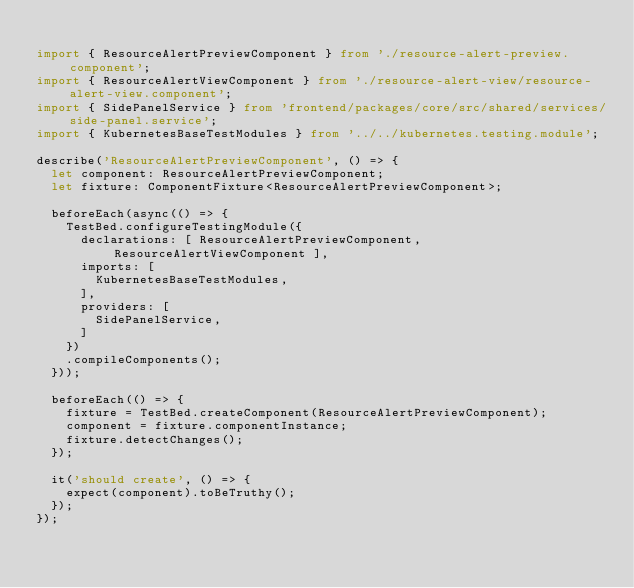Convert code to text. <code><loc_0><loc_0><loc_500><loc_500><_TypeScript_>
import { ResourceAlertPreviewComponent } from './resource-alert-preview.component';
import { ResourceAlertViewComponent } from './resource-alert-view/resource-alert-view.component';
import { SidePanelService } from 'frontend/packages/core/src/shared/services/side-panel.service';
import { KubernetesBaseTestModules } from '../../kubernetes.testing.module';

describe('ResourceAlertPreviewComponent', () => {
  let component: ResourceAlertPreviewComponent;
  let fixture: ComponentFixture<ResourceAlertPreviewComponent>;

  beforeEach(async(() => {
    TestBed.configureTestingModule({
      declarations: [ ResourceAlertPreviewComponent, ResourceAlertViewComponent ],
      imports: [
        KubernetesBaseTestModules,
      ],
      providers: [
        SidePanelService,
      ]
    })
    .compileComponents();
  }));

  beforeEach(() => {
    fixture = TestBed.createComponent(ResourceAlertPreviewComponent);
    component = fixture.componentInstance;
    fixture.detectChanges();
  });

  it('should create', () => {
    expect(component).toBeTruthy();
  });
});
</code> 